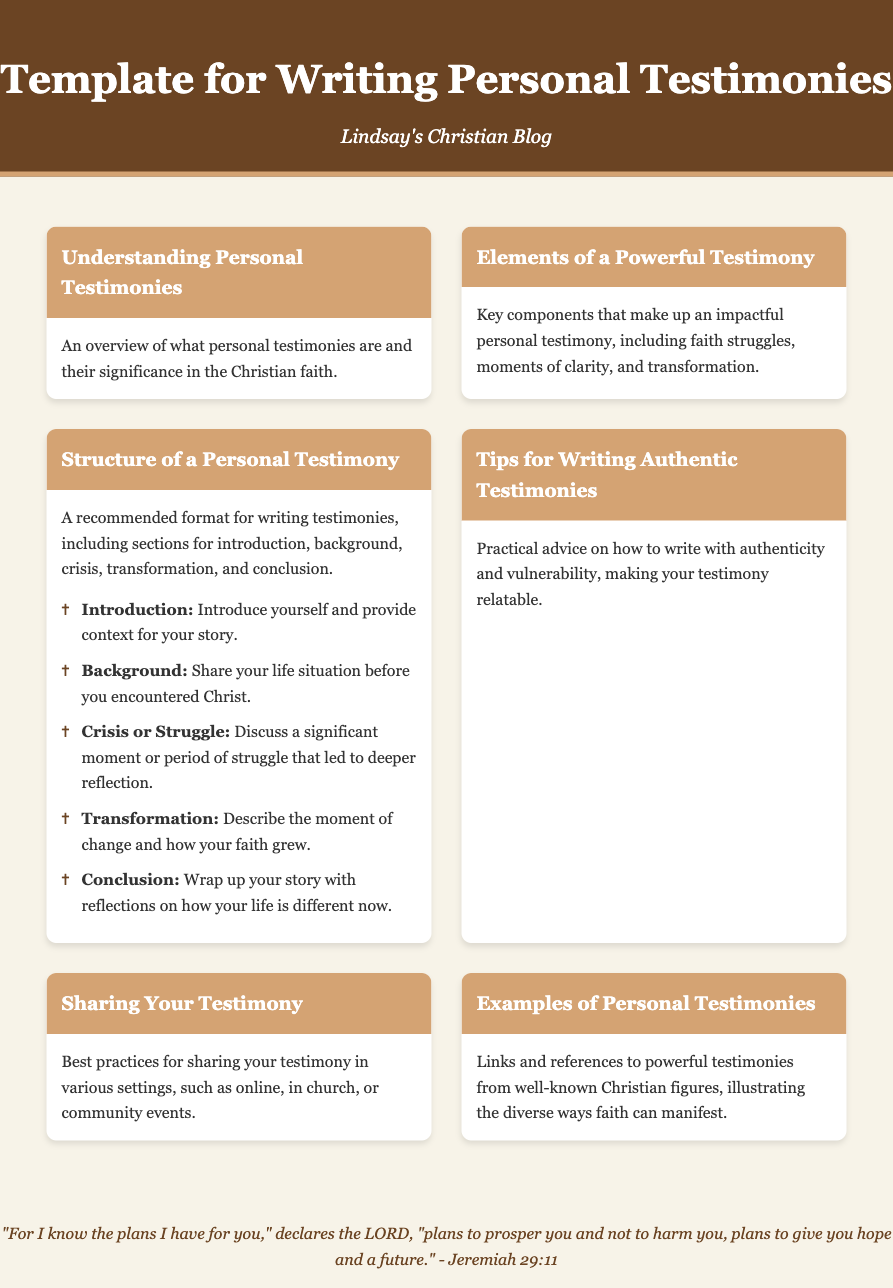what is the title of the document? The title is indicated in the header of the document, which reads "Template for Writing Personal Testimonies."
Answer: Template for Writing Personal Testimonies who is the author of the blog? The author's name is mentioned in the subtitle under the title, stating "Lindsay's Christian Blog."
Answer: Lindsay how many key sections are listed in the structure of a personal testimony? The structure outlines a total of five key sections, which are mentioned in the bullet points provided.
Answer: 5 what is the first element listed for writing a personal testimony? The first element in the structure section is titled "Introduction," providing details for that part of the testimony.
Answer: Introduction what is the purpose of personal testimonies? The overview in the first menu item states that personal testimonies hold significance in the Christian faith.
Answer: Significance which menu item provides practical tips for writing? The item that offers practical advice is titled "Tips for Writing Authentic Testimonies."
Answer: Tips for Writing Authentic Testimonies what is included in the conclusion section of a testimony? The conclusion section is summarized as wrapping up the story with reflections on how life has changed.
Answer: Reflections on how your life is different now what scripture is quoted in the footer? The footer cites a well-known verse from the book of Jeremiah, specifically Jeremiah 29:11.
Answer: Jeremiah 29:11 